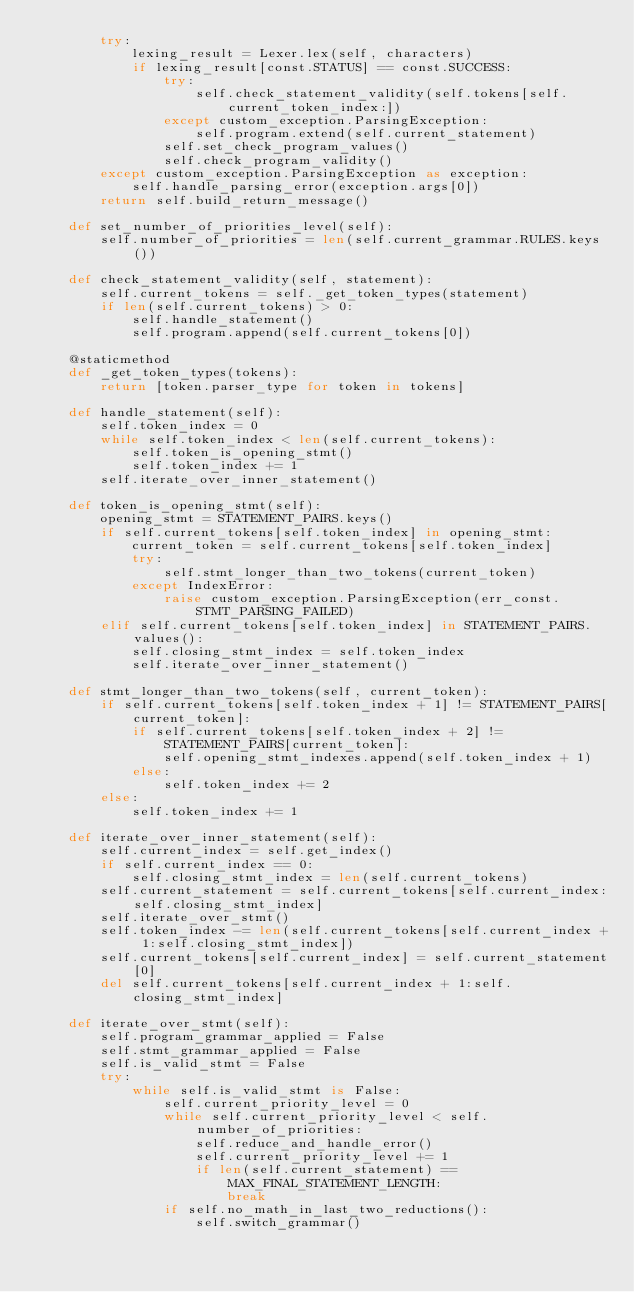<code> <loc_0><loc_0><loc_500><loc_500><_Python_>        try:
            lexing_result = Lexer.lex(self, characters)
            if lexing_result[const.STATUS] == const.SUCCESS:
                try:
                    self.check_statement_validity(self.tokens[self.current_token_index:])
                except custom_exception.ParsingException:
                    self.program.extend(self.current_statement)
                self.set_check_program_values()
                self.check_program_validity()
        except custom_exception.ParsingException as exception:
            self.handle_parsing_error(exception.args[0])
        return self.build_return_message()

    def set_number_of_priorities_level(self):
        self.number_of_priorities = len(self.current_grammar.RULES.keys())

    def check_statement_validity(self, statement):
        self.current_tokens = self._get_token_types(statement)
        if len(self.current_tokens) > 0:
            self.handle_statement()
            self.program.append(self.current_tokens[0])

    @staticmethod
    def _get_token_types(tokens):
        return [token.parser_type for token in tokens]

    def handle_statement(self):
        self.token_index = 0
        while self.token_index < len(self.current_tokens):
            self.token_is_opening_stmt()
            self.token_index += 1
        self.iterate_over_inner_statement()

    def token_is_opening_stmt(self):
        opening_stmt = STATEMENT_PAIRS.keys()
        if self.current_tokens[self.token_index] in opening_stmt:
            current_token = self.current_tokens[self.token_index]
            try:
                self.stmt_longer_than_two_tokens(current_token)
            except IndexError:
                raise custom_exception.ParsingException(err_const.STMT_PARSING_FAILED)
        elif self.current_tokens[self.token_index] in STATEMENT_PAIRS.values():
            self.closing_stmt_index = self.token_index
            self.iterate_over_inner_statement()

    def stmt_longer_than_two_tokens(self, current_token):
        if self.current_tokens[self.token_index + 1] != STATEMENT_PAIRS[current_token]:
            if self.current_tokens[self.token_index + 2] != STATEMENT_PAIRS[current_token]:
                self.opening_stmt_indexes.append(self.token_index + 1)
            else:
                self.token_index += 2
        else:
            self.token_index += 1

    def iterate_over_inner_statement(self):
        self.current_index = self.get_index()
        if self.current_index == 0:
            self.closing_stmt_index = len(self.current_tokens)
        self.current_statement = self.current_tokens[self.current_index:self.closing_stmt_index]
        self.iterate_over_stmt()
        self.token_index -= len(self.current_tokens[self.current_index + 1:self.closing_stmt_index])
        self.current_tokens[self.current_index] = self.current_statement[0]
        del self.current_tokens[self.current_index + 1:self.closing_stmt_index]

    def iterate_over_stmt(self):
        self.program_grammar_applied = False
        self.stmt_grammar_applied = False
        self.is_valid_stmt = False
        try:
            while self.is_valid_stmt is False:
                self.current_priority_level = 0
                while self.current_priority_level < self.number_of_priorities:
                    self.reduce_and_handle_error()
                    self.current_priority_level += 1
                    if len(self.current_statement) == MAX_FINAL_STATEMENT_LENGTH:
                        break
                if self.no_math_in_last_two_reductions():
                    self.switch_grammar()</code> 